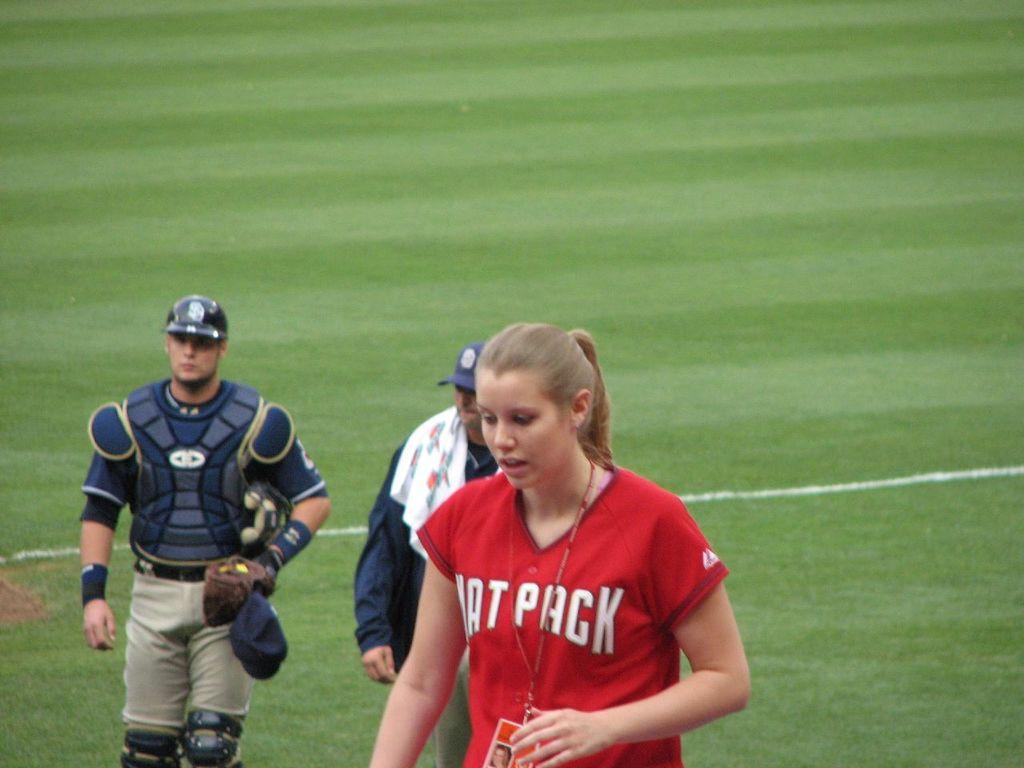What is the name of the team the girl in red plays for?
Give a very brief answer. Rat pack. 